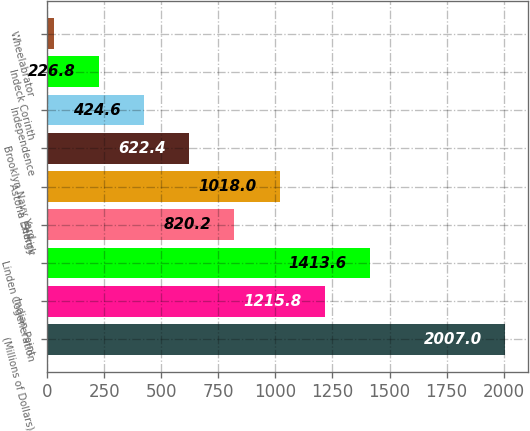<chart> <loc_0><loc_0><loc_500><loc_500><bar_chart><fcel>(Millions of Dollars)<fcel>Indian Point<fcel>Linden Cogeneration<fcel>Selkirk<fcel>Astoria Energy<fcel>Brooklyn Navy Yard<fcel>Independence<fcel>Indeck Corinth<fcel>Wheelabrator<nl><fcel>2007<fcel>1215.8<fcel>1413.6<fcel>820.2<fcel>1018<fcel>622.4<fcel>424.6<fcel>226.8<fcel>29<nl></chart> 